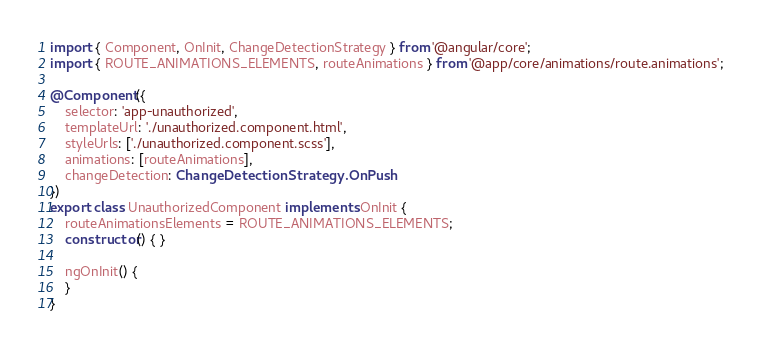Convert code to text. <code><loc_0><loc_0><loc_500><loc_500><_TypeScript_>import { Component, OnInit, ChangeDetectionStrategy } from '@angular/core';
import { ROUTE_ANIMATIONS_ELEMENTS, routeAnimations } from '@app/core/animations/route.animations';

@Component({
    selector: 'app-unauthorized',
    templateUrl: './unauthorized.component.html',
    styleUrls: ['./unauthorized.component.scss'],
    animations: [routeAnimations],
    changeDetection: ChangeDetectionStrategy.OnPush
})
export class UnauthorizedComponent implements OnInit {
    routeAnimationsElements = ROUTE_ANIMATIONS_ELEMENTS;
    constructor() { }

    ngOnInit() {
    }
}
</code> 